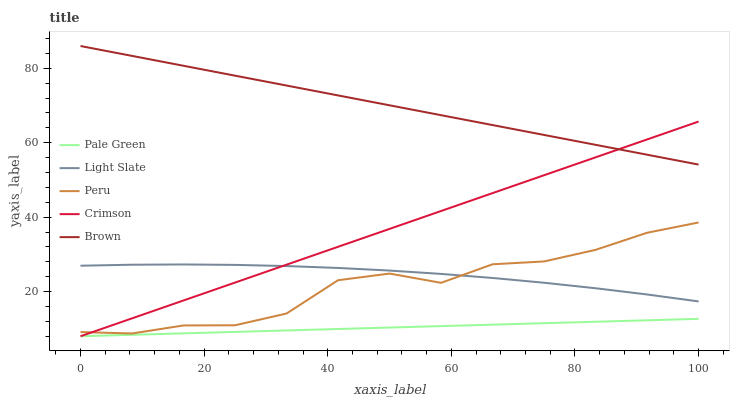Does Pale Green have the minimum area under the curve?
Answer yes or no. Yes. Does Brown have the maximum area under the curve?
Answer yes or no. Yes. Does Crimson have the minimum area under the curve?
Answer yes or no. No. Does Crimson have the maximum area under the curve?
Answer yes or no. No. Is Pale Green the smoothest?
Answer yes or no. Yes. Is Peru the roughest?
Answer yes or no. Yes. Is Crimson the smoothest?
Answer yes or no. No. Is Crimson the roughest?
Answer yes or no. No. Does Crimson have the lowest value?
Answer yes or no. Yes. Does Peru have the lowest value?
Answer yes or no. No. Does Brown have the highest value?
Answer yes or no. Yes. Does Crimson have the highest value?
Answer yes or no. No. Is Peru less than Brown?
Answer yes or no. Yes. Is Brown greater than Peru?
Answer yes or no. Yes. Does Light Slate intersect Crimson?
Answer yes or no. Yes. Is Light Slate less than Crimson?
Answer yes or no. No. Is Light Slate greater than Crimson?
Answer yes or no. No. Does Peru intersect Brown?
Answer yes or no. No. 